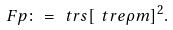<formula> <loc_0><loc_0><loc_500><loc_500>\ F p \colon = \ t r s { [ \ t r e { \rho m } ] ^ { 2 } } .</formula> 